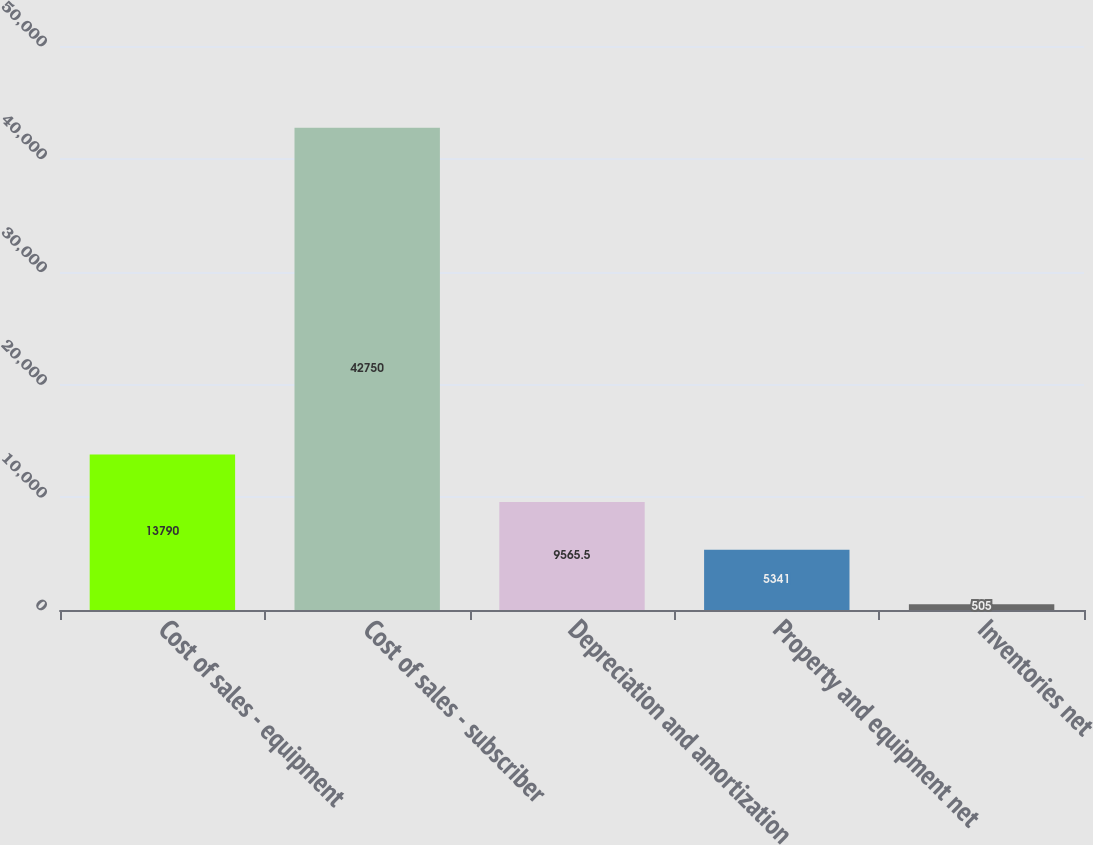<chart> <loc_0><loc_0><loc_500><loc_500><bar_chart><fcel>Cost of sales - equipment<fcel>Cost of sales - subscriber<fcel>Depreciation and amortization<fcel>Property and equipment net<fcel>Inventories net<nl><fcel>13790<fcel>42750<fcel>9565.5<fcel>5341<fcel>505<nl></chart> 